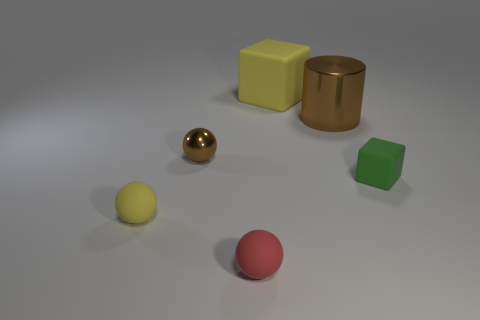Is the number of large brown metal blocks greater than the number of blocks?
Keep it short and to the point. No. There is a brown shiny object to the left of the brown shiny cylinder; what number of tiny objects are right of it?
Provide a succinct answer. 2. How many objects are rubber blocks behind the brown shiny ball or large brown metallic blocks?
Ensure brevity in your answer.  1. Are there any tiny brown shiny objects of the same shape as the green object?
Give a very brief answer. No. The matte thing that is behind the rubber block in front of the large matte cube is what shape?
Offer a very short reply. Cube. How many spheres are large shiny things or green rubber things?
Your answer should be compact. 0. What is the material of the small sphere that is the same color as the large cube?
Ensure brevity in your answer.  Rubber. Is the shape of the brown thing that is on the left side of the small red matte sphere the same as the tiny object that is right of the brown shiny cylinder?
Your answer should be very brief. No. What color is the small object that is to the left of the big rubber block and behind the tiny yellow ball?
Your response must be concise. Brown. Is the color of the tiny block the same as the object that is in front of the tiny yellow rubber object?
Offer a terse response. No. 